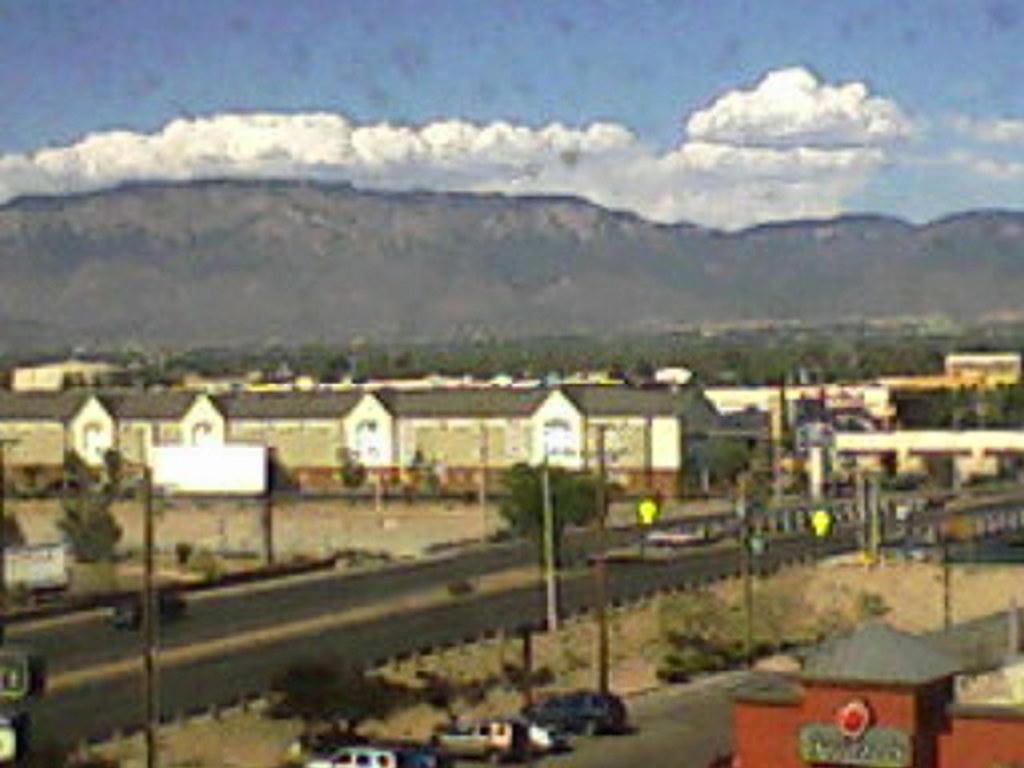What type of structures can be seen in the image? There are buildings in the image. What other objects are present in the image? There are poles, trees, mountains, and vehicles on the road in the image. What part of the natural environment is visible in the image? Trees and mountains are visible in the image. What is visible in the sky in the image? Sky is visible in the image. How many legs can be seen on the giants in the image? There are no giants present in the image, so there are no legs to count. What type of cracker is being used to hold up the buildings in the image? There is no cracker present in the image, and the buildings are not being held up by any crackers. 